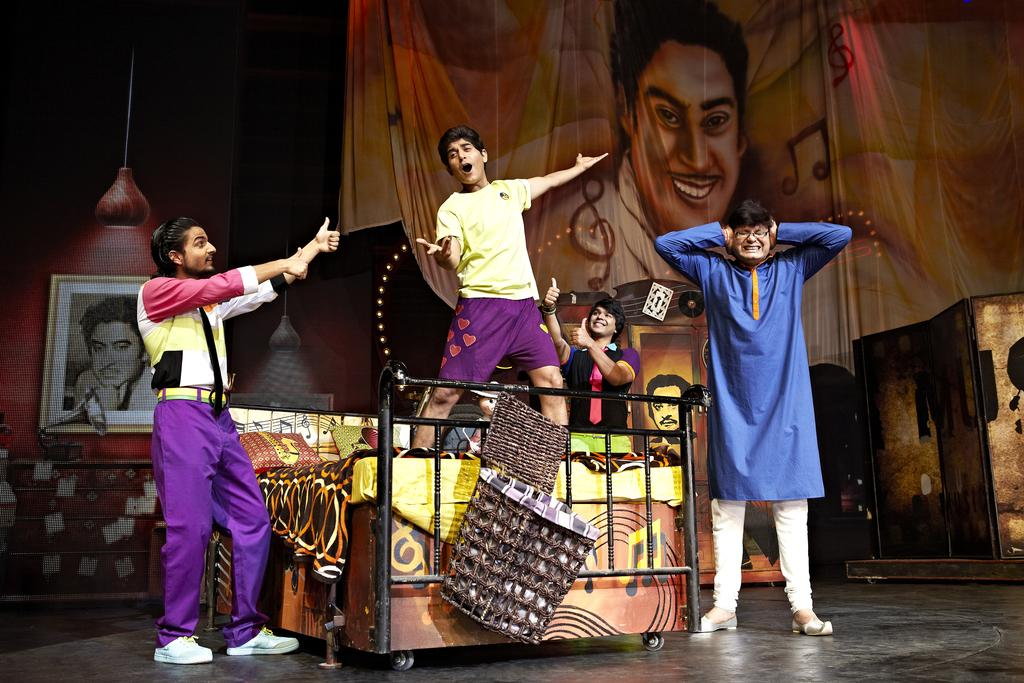What is hanging or displayed in the image? There is a banner in the image. Who or what can be seen in the image? There are people in the image. What object is present that might hold a picture or photograph? There is a photo frame in the image. What source of illumination is visible in the image? There is a light in the image. What type of floor covering is present in the image? There are mats in the image. What type of furniture is present in the image? There is a bed in the image. What type of liquid is being poured from the banner in the image? There is no liquid being poured from the banner in the image; it is a stationary banner. How many times do the people in the image twist around before sitting on the bed? There is no indication of any twisting or movement by the people in the image; they are simply standing or sitting. 